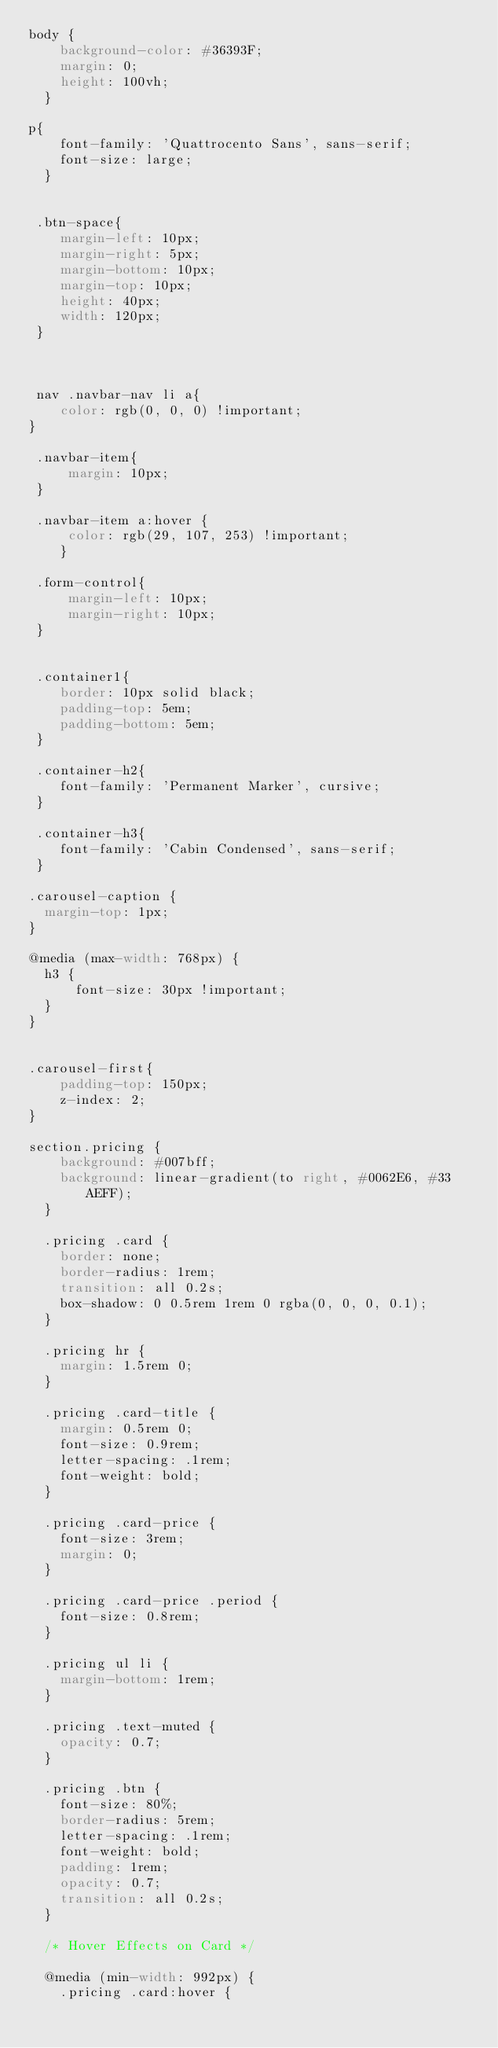<code> <loc_0><loc_0><loc_500><loc_500><_CSS_>body {
    background-color: #36393F;
    margin: 0;
    height: 100vh;
  }

p{
    font-family: 'Quattrocento Sans', sans-serif;
    font-size: large;
  }


 .btn-space{
    margin-left: 10px;
    margin-right: 5px;
    margin-bottom: 10px;
    margin-top: 10px;
    height: 40px;
    width: 120px;
 }



 nav .navbar-nav li a{
    color: rgb(0, 0, 0) !important;
}

 .navbar-item{
     margin: 10px;
 }

 .navbar-item a:hover { 
     color: rgb(29, 107, 253) !important; 
    }

 .form-control{
     margin-left: 10px;
     margin-right: 10px;
 }


 .container1{
    border: 10px solid black;
    padding-top: 5em;
    padding-bottom: 5em;
 }

 .container-h2{
    font-family: 'Permanent Marker', cursive;
 }

 .container-h3{
    font-family: 'Cabin Condensed', sans-serif;
 }

.carousel-caption {
  margin-top: 1px;
}

@media (max-width: 768px) {
  h3 {
      font-size: 30px !important;
  }
}


.carousel-first{
    padding-top: 150px;
    z-index: 2;
}

section.pricing {
    background: #007bff;
    background: linear-gradient(to right, #0062E6, #33AEFF);
  }
  
  .pricing .card {
    border: none;
    border-radius: 1rem;
    transition: all 0.2s;
    box-shadow: 0 0.5rem 1rem 0 rgba(0, 0, 0, 0.1);
  }
  
  .pricing hr {
    margin: 1.5rem 0;
  }
  
  .pricing .card-title {
    margin: 0.5rem 0;
    font-size: 0.9rem;
    letter-spacing: .1rem;
    font-weight: bold;
  }
  
  .pricing .card-price {
    font-size: 3rem;
    margin: 0;
  }
  
  .pricing .card-price .period {
    font-size: 0.8rem;
  }
  
  .pricing ul li {
    margin-bottom: 1rem;
  }
  
  .pricing .text-muted {
    opacity: 0.7;
  }
  
  .pricing .btn {
    font-size: 80%;
    border-radius: 5rem;
    letter-spacing: .1rem;
    font-weight: bold;
    padding: 1rem;
    opacity: 0.7;
    transition: all 0.2s;
  }
  
  /* Hover Effects on Card */
  
  @media (min-width: 992px) {
    .pricing .card:hover {</code> 